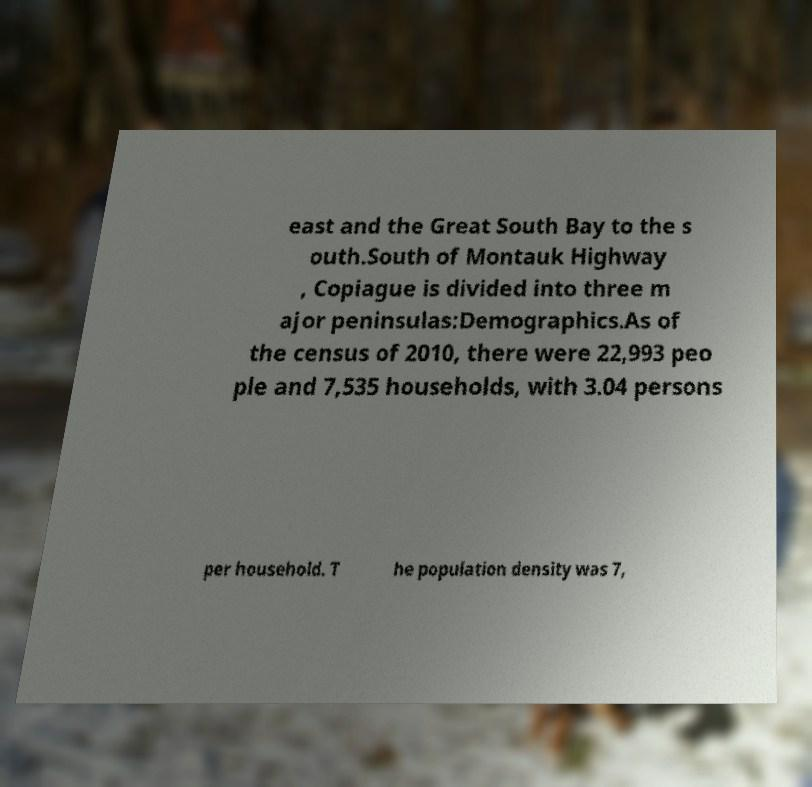I need the written content from this picture converted into text. Can you do that? east and the Great South Bay to the s outh.South of Montauk Highway , Copiague is divided into three m ajor peninsulas:Demographics.As of the census of 2010, there were 22,993 peo ple and 7,535 households, with 3.04 persons per household. T he population density was 7, 